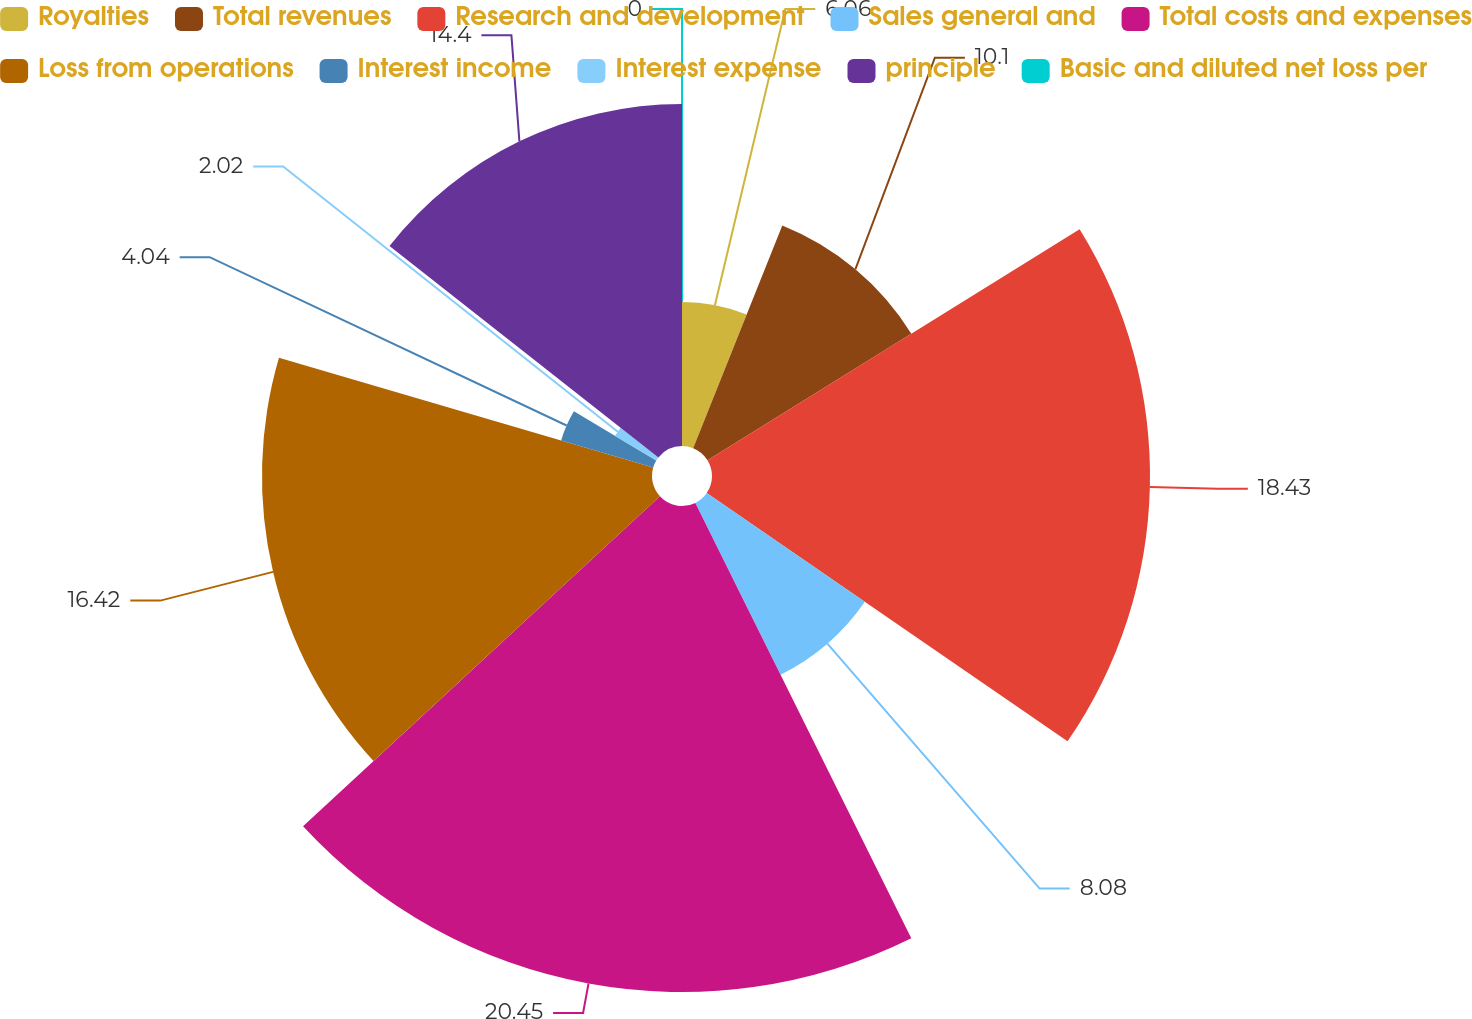<chart> <loc_0><loc_0><loc_500><loc_500><pie_chart><fcel>Royalties<fcel>Total revenues<fcel>Research and development<fcel>Sales general and<fcel>Total costs and expenses<fcel>Loss from operations<fcel>Interest income<fcel>Interest expense<fcel>principle<fcel>Basic and diluted net loss per<nl><fcel>6.06%<fcel>10.1%<fcel>18.44%<fcel>8.08%<fcel>20.46%<fcel>16.42%<fcel>4.04%<fcel>2.02%<fcel>14.4%<fcel>0.0%<nl></chart> 